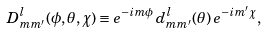<formula> <loc_0><loc_0><loc_500><loc_500>D ^ { l } _ { m m ^ { \prime } } ( \phi , \theta , \chi ) \equiv e ^ { - i m \phi } \, d ^ { l } _ { m m ^ { \prime } } ( \theta ) \, e ^ { - i m ^ { \prime } \chi } ,</formula> 